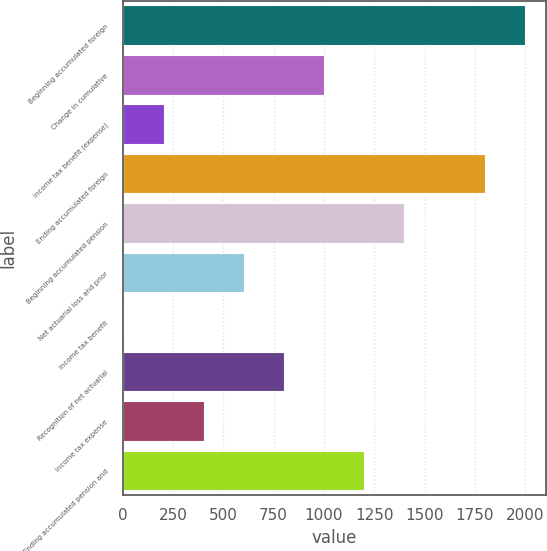Convert chart. <chart><loc_0><loc_0><loc_500><loc_500><bar_chart><fcel>Beginning accumulated foreign<fcel>Change in cumulative<fcel>Income tax benefit (expense)<fcel>Ending accumulated foreign<fcel>Beginning accumulated pension<fcel>Net actuarial loss and prior<fcel>Income tax benefit<fcel>Recognition of net actuarial<fcel>Income tax expense<fcel>Ending accumulated pension and<nl><fcel>2000.5<fcel>1000.5<fcel>206.5<fcel>1802<fcel>1397.5<fcel>603.5<fcel>8<fcel>802<fcel>405<fcel>1199<nl></chart> 